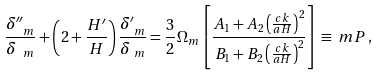Convert formula to latex. <formula><loc_0><loc_0><loc_500><loc_500>\frac { \delta ^ { \prime \prime } _ { \ m } } { \delta _ { \ m } } & + \left ( 2 + \frac { H ^ { \prime } } { H } \right ) \frac { \delta ^ { \prime } _ { \ m } } { \delta _ { \ m } } = \frac { 3 } { 2 } \Omega _ { m } \left [ \frac { A _ { 1 } + A _ { 2 } \left ( \frac { c k } { a H } \right ) ^ { 2 } } { B _ { 1 } + B _ { 2 } \left ( \frac { c k } { a H } \right ) ^ { 2 } } \right ] \equiv \ m P \, ,</formula> 